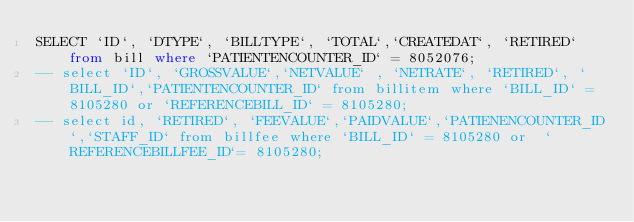<code> <loc_0><loc_0><loc_500><loc_500><_SQL_>SELECT `ID`, `DTYPE`, `BILLTYPE`, `TOTAL`,`CREATEDAT`, `RETIRED` from bill where `PATIENTENCOUNTER_ID` = 8052076;
-- select `ID`, `GROSSVALUE`,`NETVALUE` , `NETRATE`, `RETIRED`, `BILL_ID`,`PATIENTENCOUNTER_ID` from billitem where `BILL_ID` = 8105280 or `REFERENCEBILL_ID` = 8105280;
-- select id, `RETIRED`, `FEEVALUE`,`PAIDVALUE`,`PATIENENCOUNTER_ID`,`STAFF_ID` from billfee where `BILL_ID` = 8105280 or  `REFERENCEBILLFEE_ID`= 8105280;</code> 